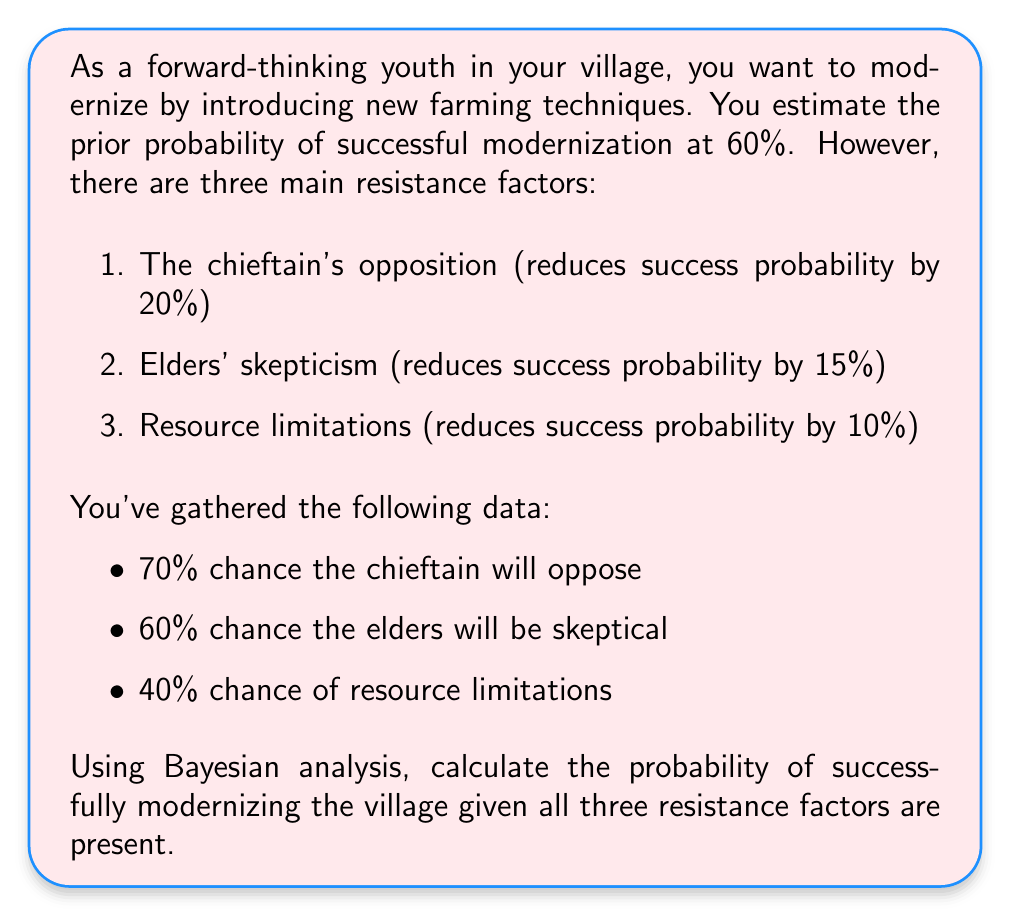Can you solve this math problem? Let's approach this step-by-step using Bayesian analysis:

1) Define events:
   M: Successful modernization
   C: Chieftain's opposition
   E: Elders' skepticism
   R: Resource limitations

2) Given probabilities:
   P(M) = 0.60 (prior probability)
   P(C) = 0.70
   P(E) = 0.60
   P(R) = 0.40

3) Impact of resistance factors:
   P(M|C) = P(M) - 0.20 = 0.40
   P(M|E) = P(M) - 0.15 = 0.45
   P(M|R) = P(M) - 0.10 = 0.50

4) We need to calculate P(M|C,E,R) using Bayes' theorem:

   $$P(M|C,E,R) = \frac{P(C,E,R|M) \cdot P(M)}{P(C,E,R)}$$

5) Assuming independence of resistance factors:

   $$P(C,E,R|M) = P(C|M) \cdot P(E|M) \cdot P(R|M)$$

6) Calculate P(C|M), P(E|M), P(R|M) using Bayes' theorem:

   $$P(C|M) = \frac{P(M|C) \cdot P(C)}{P(M)} = \frac{0.40 \cdot 0.70}{0.60} = 0.4667$$

   $$P(E|M) = \frac{P(M|E) \cdot P(E)}{P(M)} = \frac{0.45 \cdot 0.60}{0.60} = 0.4500$$

   $$P(R|M) = \frac{P(M|R) \cdot P(R)}{P(M)} = \frac{0.50 \cdot 0.40}{0.60} = 0.3333$$

7) Now calculate P(C,E,R|M):

   $$P(C,E,R|M) = 0.4667 \cdot 0.4500 \cdot 0.3333 = 0.0700$$

8) Calculate P(C,E,R):

   $$P(C,E,R) = P(C) \cdot P(E) \cdot P(R) = 0.70 \cdot 0.60 \cdot 0.40 = 0.1680$$

9) Finally, calculate P(M|C,E,R):

   $$P(M|C,E,R) = \frac{0.0700 \cdot 0.60}{0.1680} = 0.2500$$

Therefore, the probability of successfully modernizing the village given all three resistance factors are present is 0.2500 or 25%.
Answer: 0.2500 or 25% 